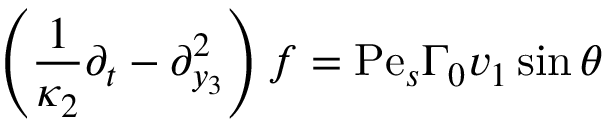<formula> <loc_0><loc_0><loc_500><loc_500>\left ( \frac { 1 } { \kappa _ { 2 } } \partial _ { t } - \partial _ { y _ { 3 } } ^ { 2 } \right ) f = P e _ { s } \Gamma _ { 0 } v _ { 1 } \sin \theta</formula> 